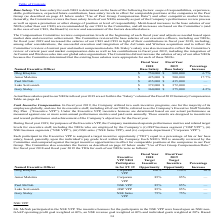According to Viavi Solutions's financial document, When does the Compensation Committee review compensation levels? at the beginning of each fiscal year. The document states: "ompensation Committee reviews compensation levels at the beginning of each fiscal year and adjusts as needed based upon market data and executive achi..." Also, What was Oleg Khaykin's base salary in 2018? According to the financial document, $750,000. The relevant text states: "Oleg Khaykin $ 750,000 $ 800,000 6.7%..." Also, What was Gary Staley's base salary in 2018? According to the financial document, $360,000. The relevant text states: "Gary Staley $ 360,000 $ 375,000 4.2%..." Also, can you calculate: What was the total base salary of all Named Executive Officers in 2018? Based on the calculation: ($750,000+$425,000+$435,000+$372,000+$360,000), the result is 2342000. This is based on the information: "Amar Maletira $ 425,000 $ 500,000 17.7% Paul McNab $ 435,000 $ 435,000 — Luke Scrivanich $ 372,000 $ 372,000 — Oleg Khaykin $ 750,000 $ 800,000 6.7% Gary Staley $ 360,000 $ 375,000 4.2%..." The key data points involved are: 360,000, 372,000, 425,000. Also, can you calculate: How much do the top 3 base salaries in 2019 add up to? Based on the calculation: ($800,000+$500,000+$435,000), the result is 1735000. This is based on the information: "Oleg Khaykin $ 750,000 $ 800,000 6.7% Amar Maletira $ 425,000 $ 500,000 17.7% Paul McNab $ 435,000 $ 435,000 —..." The key data points involved are: 435,000, 500,000, 800,000. Also, can you calculate: What is the difference in base salary between Paul McNab and Luke Scrivanch in 2018? Based on the calculation: ($435,000-$372,000), the result is 63000. This is based on the information: "Paul McNab $ 435,000 $ 435,000 — Luke Scrivanich $ 372,000 $ 372,000 —..." The key data points involved are: 372,000, 435,000. 